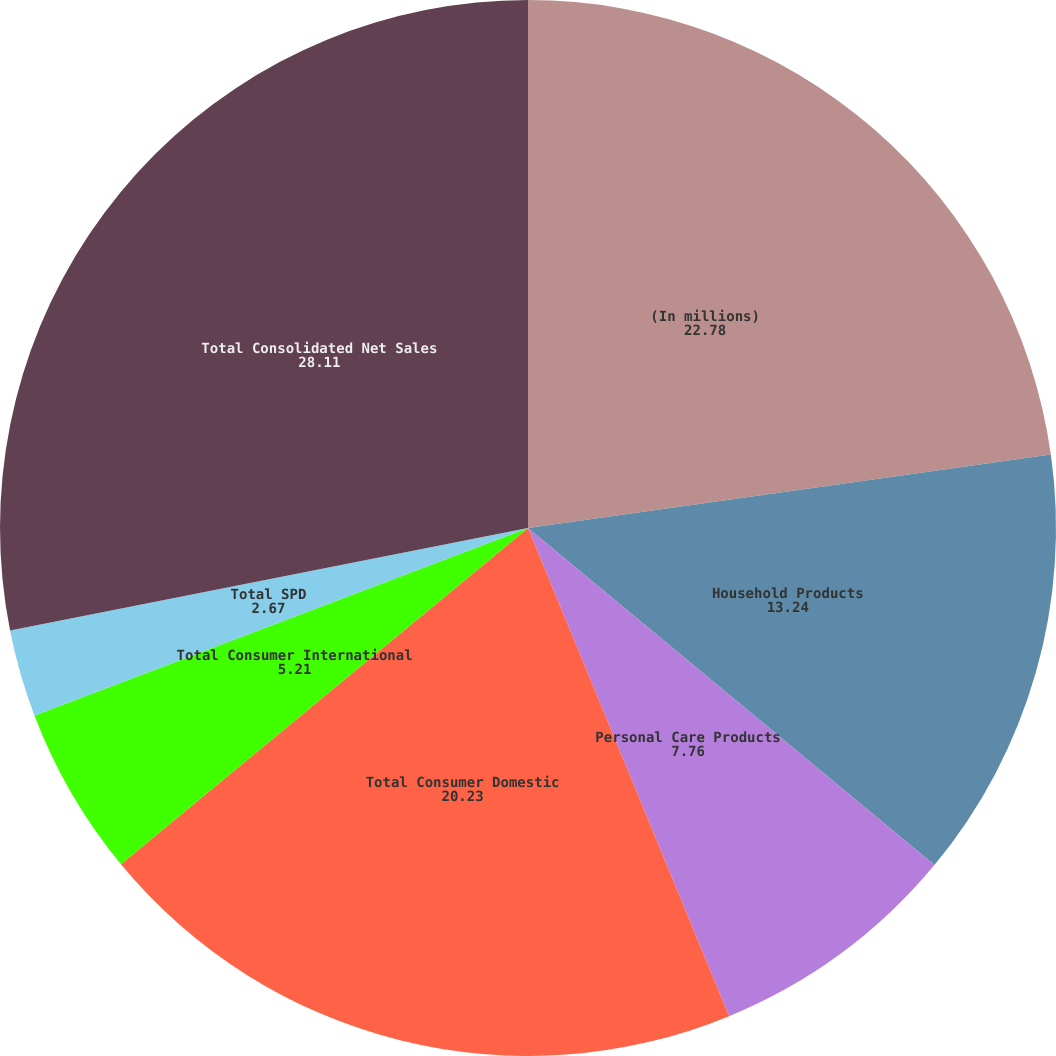<chart> <loc_0><loc_0><loc_500><loc_500><pie_chart><fcel>(In millions)<fcel>Household Products<fcel>Personal Care Products<fcel>Total Consumer Domestic<fcel>Total Consumer International<fcel>Total SPD<fcel>Total Consolidated Net Sales<nl><fcel>22.78%<fcel>13.24%<fcel>7.76%<fcel>20.23%<fcel>5.21%<fcel>2.67%<fcel>28.11%<nl></chart> 